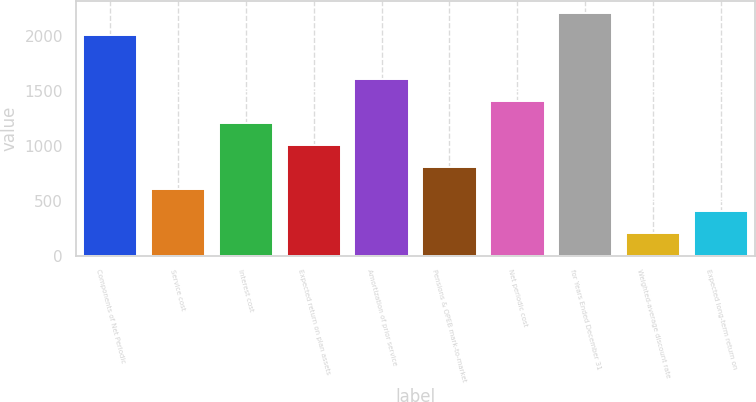<chart> <loc_0><loc_0><loc_500><loc_500><bar_chart><fcel>Components of Net Periodic<fcel>Service cost<fcel>Interest cost<fcel>Expected return on plan assets<fcel>Amortization of prior service<fcel>Pensions & OPEB mark-to-market<fcel>Net periodic cost<fcel>for Years Ended December 31<fcel>Weighted-average discount rate<fcel>Expected long-term return on<nl><fcel>2009<fcel>606.34<fcel>1207.48<fcel>1007.1<fcel>1608.24<fcel>806.72<fcel>1407.86<fcel>2209.38<fcel>205.58<fcel>405.96<nl></chart> 